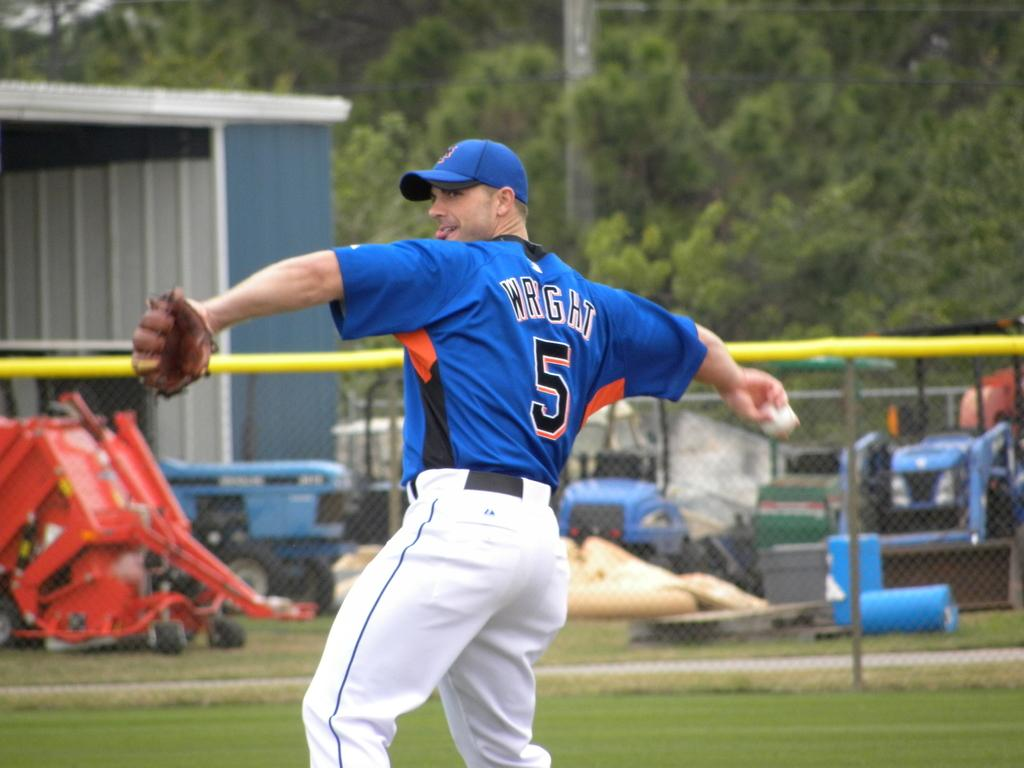Provide a one-sentence caption for the provided image. a baseball player with the name Wright on his jersey #5. 